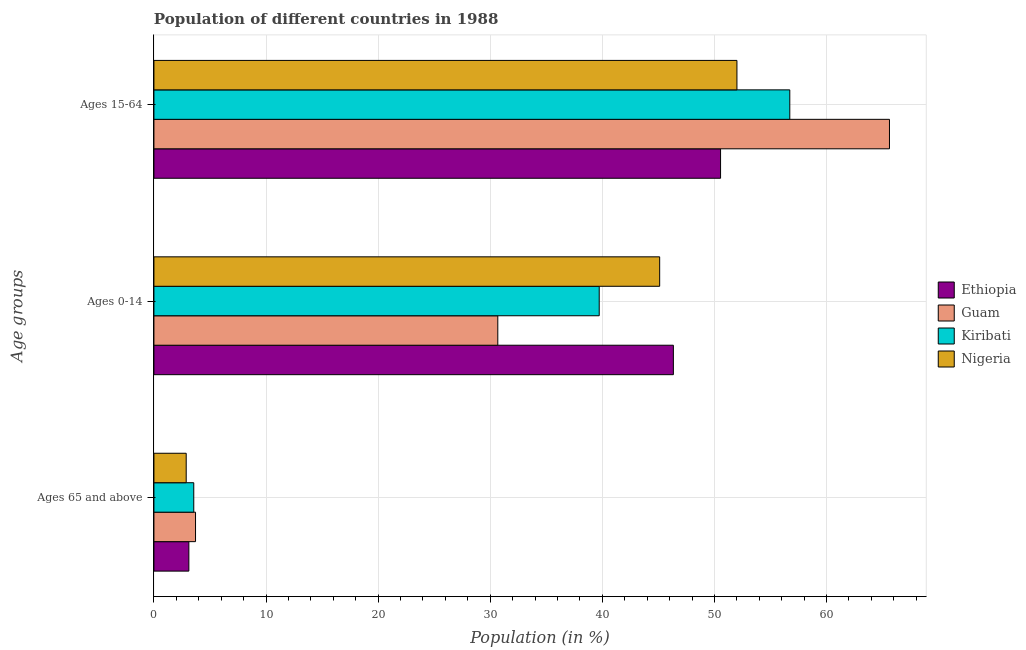How many groups of bars are there?
Your answer should be compact. 3. How many bars are there on the 2nd tick from the bottom?
Your answer should be very brief. 4. What is the label of the 3rd group of bars from the top?
Your answer should be very brief. Ages 65 and above. What is the percentage of population within the age-group 0-14 in Ethiopia?
Give a very brief answer. 46.34. Across all countries, what is the maximum percentage of population within the age-group 15-64?
Give a very brief answer. 65.61. Across all countries, what is the minimum percentage of population within the age-group 0-14?
Your answer should be compact. 30.67. In which country was the percentage of population within the age-group 15-64 maximum?
Your answer should be very brief. Guam. In which country was the percentage of population within the age-group 0-14 minimum?
Make the answer very short. Guam. What is the total percentage of population within the age-group 15-64 in the graph?
Ensure brevity in your answer.  224.89. What is the difference between the percentage of population within the age-group 0-14 in Kiribati and that in Nigeria?
Your response must be concise. -5.39. What is the difference between the percentage of population within the age-group 15-64 in Guam and the percentage of population within the age-group 0-14 in Kiribati?
Ensure brevity in your answer.  25.89. What is the average percentage of population within the age-group of 65 and above per country?
Give a very brief answer. 3.32. What is the difference between the percentage of population within the age-group 0-14 and percentage of population within the age-group 15-64 in Guam?
Your answer should be very brief. -34.94. What is the ratio of the percentage of population within the age-group 0-14 in Kiribati to that in Ethiopia?
Your answer should be very brief. 0.86. What is the difference between the highest and the second highest percentage of population within the age-group 0-14?
Offer a very short reply. 1.22. What is the difference between the highest and the lowest percentage of population within the age-group 0-14?
Offer a terse response. 15.66. Is the sum of the percentage of population within the age-group of 65 and above in Nigeria and Guam greater than the maximum percentage of population within the age-group 15-64 across all countries?
Keep it short and to the point. No. What does the 3rd bar from the top in Ages 15-64 represents?
Give a very brief answer. Guam. What does the 2nd bar from the bottom in Ages 65 and above represents?
Your answer should be compact. Guam. How many bars are there?
Your response must be concise. 12. How many countries are there in the graph?
Offer a terse response. 4. Does the graph contain any zero values?
Your answer should be compact. No. Does the graph contain grids?
Provide a succinct answer. Yes. How many legend labels are there?
Keep it short and to the point. 4. What is the title of the graph?
Keep it short and to the point. Population of different countries in 1988. What is the label or title of the X-axis?
Your answer should be compact. Population (in %). What is the label or title of the Y-axis?
Keep it short and to the point. Age groups. What is the Population (in %) in Ethiopia in Ages 65 and above?
Offer a very short reply. 3.12. What is the Population (in %) in Guam in Ages 65 and above?
Ensure brevity in your answer.  3.71. What is the Population (in %) of Kiribati in Ages 65 and above?
Provide a short and direct response. 3.55. What is the Population (in %) of Nigeria in Ages 65 and above?
Make the answer very short. 2.88. What is the Population (in %) of Ethiopia in Ages 0-14?
Provide a short and direct response. 46.34. What is the Population (in %) in Guam in Ages 0-14?
Provide a succinct answer. 30.67. What is the Population (in %) of Kiribati in Ages 0-14?
Your response must be concise. 39.72. What is the Population (in %) in Nigeria in Ages 0-14?
Keep it short and to the point. 45.11. What is the Population (in %) of Ethiopia in Ages 15-64?
Make the answer very short. 50.55. What is the Population (in %) in Guam in Ages 15-64?
Ensure brevity in your answer.  65.61. What is the Population (in %) of Kiribati in Ages 15-64?
Make the answer very short. 56.72. What is the Population (in %) in Nigeria in Ages 15-64?
Your response must be concise. 52.01. Across all Age groups, what is the maximum Population (in %) of Ethiopia?
Offer a very short reply. 50.55. Across all Age groups, what is the maximum Population (in %) of Guam?
Ensure brevity in your answer.  65.61. Across all Age groups, what is the maximum Population (in %) in Kiribati?
Keep it short and to the point. 56.72. Across all Age groups, what is the maximum Population (in %) of Nigeria?
Your answer should be very brief. 52.01. Across all Age groups, what is the minimum Population (in %) in Ethiopia?
Your answer should be very brief. 3.12. Across all Age groups, what is the minimum Population (in %) of Guam?
Give a very brief answer. 3.71. Across all Age groups, what is the minimum Population (in %) in Kiribati?
Provide a short and direct response. 3.55. Across all Age groups, what is the minimum Population (in %) of Nigeria?
Your response must be concise. 2.88. What is the total Population (in %) of Guam in the graph?
Make the answer very short. 100. What is the total Population (in %) of Nigeria in the graph?
Ensure brevity in your answer.  100. What is the difference between the Population (in %) in Ethiopia in Ages 65 and above and that in Ages 0-14?
Your answer should be very brief. -43.22. What is the difference between the Population (in %) in Guam in Ages 65 and above and that in Ages 0-14?
Ensure brevity in your answer.  -26.96. What is the difference between the Population (in %) in Kiribati in Ages 65 and above and that in Ages 0-14?
Your answer should be compact. -36.17. What is the difference between the Population (in %) in Nigeria in Ages 65 and above and that in Ages 0-14?
Your answer should be compact. -42.24. What is the difference between the Population (in %) of Ethiopia in Ages 65 and above and that in Ages 15-64?
Make the answer very short. -47.43. What is the difference between the Population (in %) of Guam in Ages 65 and above and that in Ages 15-64?
Provide a short and direct response. -61.9. What is the difference between the Population (in %) of Kiribati in Ages 65 and above and that in Ages 15-64?
Offer a very short reply. -53.17. What is the difference between the Population (in %) of Nigeria in Ages 65 and above and that in Ages 15-64?
Provide a succinct answer. -49.13. What is the difference between the Population (in %) of Ethiopia in Ages 0-14 and that in Ages 15-64?
Offer a very short reply. -4.21. What is the difference between the Population (in %) of Guam in Ages 0-14 and that in Ages 15-64?
Provide a succinct answer. -34.94. What is the difference between the Population (in %) of Kiribati in Ages 0-14 and that in Ages 15-64?
Make the answer very short. -17. What is the difference between the Population (in %) of Nigeria in Ages 0-14 and that in Ages 15-64?
Provide a succinct answer. -6.89. What is the difference between the Population (in %) of Ethiopia in Ages 65 and above and the Population (in %) of Guam in Ages 0-14?
Ensure brevity in your answer.  -27.56. What is the difference between the Population (in %) in Ethiopia in Ages 65 and above and the Population (in %) in Kiribati in Ages 0-14?
Offer a terse response. -36.61. What is the difference between the Population (in %) of Ethiopia in Ages 65 and above and the Population (in %) of Nigeria in Ages 0-14?
Your answer should be very brief. -42. What is the difference between the Population (in %) in Guam in Ages 65 and above and the Population (in %) in Kiribati in Ages 0-14?
Your answer should be very brief. -36.01. What is the difference between the Population (in %) of Guam in Ages 65 and above and the Population (in %) of Nigeria in Ages 0-14?
Your answer should be compact. -41.4. What is the difference between the Population (in %) of Kiribati in Ages 65 and above and the Population (in %) of Nigeria in Ages 0-14?
Your response must be concise. -41.56. What is the difference between the Population (in %) of Ethiopia in Ages 65 and above and the Population (in %) of Guam in Ages 15-64?
Offer a terse response. -62.5. What is the difference between the Population (in %) in Ethiopia in Ages 65 and above and the Population (in %) in Kiribati in Ages 15-64?
Provide a succinct answer. -53.61. What is the difference between the Population (in %) in Ethiopia in Ages 65 and above and the Population (in %) in Nigeria in Ages 15-64?
Your answer should be very brief. -48.89. What is the difference between the Population (in %) in Guam in Ages 65 and above and the Population (in %) in Kiribati in Ages 15-64?
Give a very brief answer. -53.01. What is the difference between the Population (in %) in Guam in Ages 65 and above and the Population (in %) in Nigeria in Ages 15-64?
Provide a succinct answer. -48.29. What is the difference between the Population (in %) of Kiribati in Ages 65 and above and the Population (in %) of Nigeria in Ages 15-64?
Provide a short and direct response. -48.45. What is the difference between the Population (in %) in Ethiopia in Ages 0-14 and the Population (in %) in Guam in Ages 15-64?
Offer a terse response. -19.28. What is the difference between the Population (in %) in Ethiopia in Ages 0-14 and the Population (in %) in Kiribati in Ages 15-64?
Make the answer very short. -10.39. What is the difference between the Population (in %) in Ethiopia in Ages 0-14 and the Population (in %) in Nigeria in Ages 15-64?
Give a very brief answer. -5.67. What is the difference between the Population (in %) of Guam in Ages 0-14 and the Population (in %) of Kiribati in Ages 15-64?
Keep it short and to the point. -26.05. What is the difference between the Population (in %) of Guam in Ages 0-14 and the Population (in %) of Nigeria in Ages 15-64?
Your answer should be compact. -21.33. What is the difference between the Population (in %) of Kiribati in Ages 0-14 and the Population (in %) of Nigeria in Ages 15-64?
Your answer should be compact. -12.28. What is the average Population (in %) of Ethiopia per Age groups?
Your answer should be compact. 33.33. What is the average Population (in %) of Guam per Age groups?
Offer a very short reply. 33.33. What is the average Population (in %) in Kiribati per Age groups?
Ensure brevity in your answer.  33.33. What is the average Population (in %) in Nigeria per Age groups?
Ensure brevity in your answer.  33.33. What is the difference between the Population (in %) of Ethiopia and Population (in %) of Guam in Ages 65 and above?
Your answer should be compact. -0.6. What is the difference between the Population (in %) of Ethiopia and Population (in %) of Kiribati in Ages 65 and above?
Your response must be concise. -0.44. What is the difference between the Population (in %) in Ethiopia and Population (in %) in Nigeria in Ages 65 and above?
Provide a succinct answer. 0.24. What is the difference between the Population (in %) of Guam and Population (in %) of Kiribati in Ages 65 and above?
Your answer should be compact. 0.16. What is the difference between the Population (in %) of Guam and Population (in %) of Nigeria in Ages 65 and above?
Your answer should be compact. 0.83. What is the difference between the Population (in %) in Kiribati and Population (in %) in Nigeria in Ages 65 and above?
Provide a short and direct response. 0.68. What is the difference between the Population (in %) of Ethiopia and Population (in %) of Guam in Ages 0-14?
Your response must be concise. 15.66. What is the difference between the Population (in %) of Ethiopia and Population (in %) of Kiribati in Ages 0-14?
Keep it short and to the point. 6.62. What is the difference between the Population (in %) in Ethiopia and Population (in %) in Nigeria in Ages 0-14?
Provide a short and direct response. 1.22. What is the difference between the Population (in %) in Guam and Population (in %) in Kiribati in Ages 0-14?
Provide a short and direct response. -9.05. What is the difference between the Population (in %) of Guam and Population (in %) of Nigeria in Ages 0-14?
Ensure brevity in your answer.  -14.44. What is the difference between the Population (in %) of Kiribati and Population (in %) of Nigeria in Ages 0-14?
Provide a succinct answer. -5.39. What is the difference between the Population (in %) in Ethiopia and Population (in %) in Guam in Ages 15-64?
Offer a very short reply. -15.07. What is the difference between the Population (in %) of Ethiopia and Population (in %) of Kiribati in Ages 15-64?
Provide a short and direct response. -6.18. What is the difference between the Population (in %) of Ethiopia and Population (in %) of Nigeria in Ages 15-64?
Ensure brevity in your answer.  -1.46. What is the difference between the Population (in %) in Guam and Population (in %) in Kiribati in Ages 15-64?
Keep it short and to the point. 8.89. What is the difference between the Population (in %) of Guam and Population (in %) of Nigeria in Ages 15-64?
Keep it short and to the point. 13.61. What is the difference between the Population (in %) in Kiribati and Population (in %) in Nigeria in Ages 15-64?
Your answer should be compact. 4.72. What is the ratio of the Population (in %) in Ethiopia in Ages 65 and above to that in Ages 0-14?
Provide a short and direct response. 0.07. What is the ratio of the Population (in %) of Guam in Ages 65 and above to that in Ages 0-14?
Ensure brevity in your answer.  0.12. What is the ratio of the Population (in %) in Kiribati in Ages 65 and above to that in Ages 0-14?
Make the answer very short. 0.09. What is the ratio of the Population (in %) of Nigeria in Ages 65 and above to that in Ages 0-14?
Ensure brevity in your answer.  0.06. What is the ratio of the Population (in %) in Ethiopia in Ages 65 and above to that in Ages 15-64?
Make the answer very short. 0.06. What is the ratio of the Population (in %) of Guam in Ages 65 and above to that in Ages 15-64?
Offer a terse response. 0.06. What is the ratio of the Population (in %) in Kiribati in Ages 65 and above to that in Ages 15-64?
Provide a succinct answer. 0.06. What is the ratio of the Population (in %) of Nigeria in Ages 65 and above to that in Ages 15-64?
Offer a terse response. 0.06. What is the ratio of the Population (in %) of Ethiopia in Ages 0-14 to that in Ages 15-64?
Give a very brief answer. 0.92. What is the ratio of the Population (in %) of Guam in Ages 0-14 to that in Ages 15-64?
Offer a terse response. 0.47. What is the ratio of the Population (in %) in Kiribati in Ages 0-14 to that in Ages 15-64?
Provide a succinct answer. 0.7. What is the ratio of the Population (in %) of Nigeria in Ages 0-14 to that in Ages 15-64?
Ensure brevity in your answer.  0.87. What is the difference between the highest and the second highest Population (in %) in Ethiopia?
Offer a terse response. 4.21. What is the difference between the highest and the second highest Population (in %) in Guam?
Offer a very short reply. 34.94. What is the difference between the highest and the second highest Population (in %) in Kiribati?
Provide a short and direct response. 17. What is the difference between the highest and the second highest Population (in %) in Nigeria?
Make the answer very short. 6.89. What is the difference between the highest and the lowest Population (in %) of Ethiopia?
Offer a terse response. 47.43. What is the difference between the highest and the lowest Population (in %) of Guam?
Your answer should be compact. 61.9. What is the difference between the highest and the lowest Population (in %) of Kiribati?
Make the answer very short. 53.17. What is the difference between the highest and the lowest Population (in %) of Nigeria?
Your answer should be compact. 49.13. 